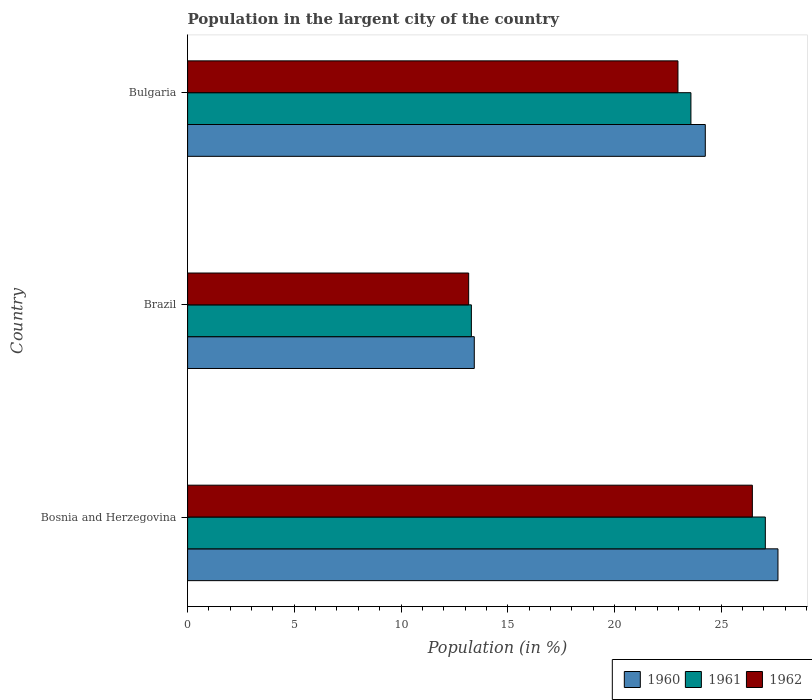How many different coloured bars are there?
Ensure brevity in your answer.  3. Are the number of bars per tick equal to the number of legend labels?
Provide a short and direct response. Yes. Are the number of bars on each tick of the Y-axis equal?
Ensure brevity in your answer.  Yes. How many bars are there on the 2nd tick from the bottom?
Your response must be concise. 3. In how many cases, is the number of bars for a given country not equal to the number of legend labels?
Your answer should be very brief. 0. What is the percentage of population in the largent city in 1961 in Brazil?
Offer a very short reply. 13.3. Across all countries, what is the maximum percentage of population in the largent city in 1961?
Ensure brevity in your answer.  27.07. Across all countries, what is the minimum percentage of population in the largent city in 1960?
Provide a succinct answer. 13.43. In which country was the percentage of population in the largent city in 1962 maximum?
Provide a succinct answer. Bosnia and Herzegovina. In which country was the percentage of population in the largent city in 1961 minimum?
Your answer should be compact. Brazil. What is the total percentage of population in the largent city in 1962 in the graph?
Give a very brief answer. 62.61. What is the difference between the percentage of population in the largent city in 1962 in Brazil and that in Bulgaria?
Give a very brief answer. -9.81. What is the difference between the percentage of population in the largent city in 1962 in Bosnia and Herzegovina and the percentage of population in the largent city in 1960 in Brazil?
Keep it short and to the point. 13.03. What is the average percentage of population in the largent city in 1962 per country?
Offer a very short reply. 20.87. What is the difference between the percentage of population in the largent city in 1960 and percentage of population in the largent city in 1962 in Brazil?
Your answer should be very brief. 0.26. What is the ratio of the percentage of population in the largent city in 1961 in Bosnia and Herzegovina to that in Bulgaria?
Keep it short and to the point. 1.15. Is the difference between the percentage of population in the largent city in 1960 in Bosnia and Herzegovina and Brazil greater than the difference between the percentage of population in the largent city in 1962 in Bosnia and Herzegovina and Brazil?
Make the answer very short. Yes. What is the difference between the highest and the second highest percentage of population in the largent city in 1960?
Your response must be concise. 3.41. What is the difference between the highest and the lowest percentage of population in the largent city in 1961?
Provide a succinct answer. 13.77. Is the sum of the percentage of population in the largent city in 1961 in Bosnia and Herzegovina and Bulgaria greater than the maximum percentage of population in the largent city in 1960 across all countries?
Your response must be concise. Yes. What does the 3rd bar from the bottom in Bosnia and Herzegovina represents?
Your answer should be compact. 1962. How many bars are there?
Your answer should be compact. 9. How many countries are there in the graph?
Give a very brief answer. 3. Are the values on the major ticks of X-axis written in scientific E-notation?
Give a very brief answer. No. Does the graph contain grids?
Ensure brevity in your answer.  No. Where does the legend appear in the graph?
Provide a succinct answer. Bottom right. How many legend labels are there?
Provide a short and direct response. 3. How are the legend labels stacked?
Your answer should be compact. Horizontal. What is the title of the graph?
Your answer should be compact. Population in the largent city of the country. What is the label or title of the X-axis?
Make the answer very short. Population (in %). What is the Population (in %) in 1960 in Bosnia and Herzegovina?
Your response must be concise. 27.66. What is the Population (in %) in 1961 in Bosnia and Herzegovina?
Offer a terse response. 27.07. What is the Population (in %) of 1962 in Bosnia and Herzegovina?
Provide a succinct answer. 26.46. What is the Population (in %) of 1960 in Brazil?
Provide a short and direct response. 13.43. What is the Population (in %) in 1961 in Brazil?
Provide a succinct answer. 13.3. What is the Population (in %) of 1962 in Brazil?
Your answer should be very brief. 13.17. What is the Population (in %) of 1960 in Bulgaria?
Your answer should be very brief. 24.26. What is the Population (in %) in 1961 in Bulgaria?
Keep it short and to the point. 23.59. What is the Population (in %) of 1962 in Bulgaria?
Provide a succinct answer. 22.98. Across all countries, what is the maximum Population (in %) in 1960?
Ensure brevity in your answer.  27.66. Across all countries, what is the maximum Population (in %) in 1961?
Provide a short and direct response. 27.07. Across all countries, what is the maximum Population (in %) in 1962?
Your response must be concise. 26.46. Across all countries, what is the minimum Population (in %) of 1960?
Your answer should be very brief. 13.43. Across all countries, what is the minimum Population (in %) of 1961?
Make the answer very short. 13.3. Across all countries, what is the minimum Population (in %) in 1962?
Offer a very short reply. 13.17. What is the total Population (in %) of 1960 in the graph?
Ensure brevity in your answer.  65.36. What is the total Population (in %) in 1961 in the graph?
Provide a short and direct response. 63.95. What is the total Population (in %) in 1962 in the graph?
Your answer should be compact. 62.61. What is the difference between the Population (in %) of 1960 in Bosnia and Herzegovina and that in Brazil?
Your response must be concise. 14.23. What is the difference between the Population (in %) of 1961 in Bosnia and Herzegovina and that in Brazil?
Keep it short and to the point. 13.77. What is the difference between the Population (in %) in 1962 in Bosnia and Herzegovina and that in Brazil?
Provide a succinct answer. 13.29. What is the difference between the Population (in %) in 1960 in Bosnia and Herzegovina and that in Bulgaria?
Provide a succinct answer. 3.41. What is the difference between the Population (in %) of 1961 in Bosnia and Herzegovina and that in Bulgaria?
Your answer should be compact. 3.49. What is the difference between the Population (in %) of 1962 in Bosnia and Herzegovina and that in Bulgaria?
Your response must be concise. 3.49. What is the difference between the Population (in %) in 1960 in Brazil and that in Bulgaria?
Offer a very short reply. -10.83. What is the difference between the Population (in %) in 1961 in Brazil and that in Bulgaria?
Your response must be concise. -10.29. What is the difference between the Population (in %) of 1962 in Brazil and that in Bulgaria?
Ensure brevity in your answer.  -9.81. What is the difference between the Population (in %) in 1960 in Bosnia and Herzegovina and the Population (in %) in 1961 in Brazil?
Your response must be concise. 14.37. What is the difference between the Population (in %) in 1960 in Bosnia and Herzegovina and the Population (in %) in 1962 in Brazil?
Ensure brevity in your answer.  14.49. What is the difference between the Population (in %) of 1961 in Bosnia and Herzegovina and the Population (in %) of 1962 in Brazil?
Provide a succinct answer. 13.9. What is the difference between the Population (in %) in 1960 in Bosnia and Herzegovina and the Population (in %) in 1961 in Bulgaria?
Offer a very short reply. 4.08. What is the difference between the Population (in %) in 1960 in Bosnia and Herzegovina and the Population (in %) in 1962 in Bulgaria?
Provide a succinct answer. 4.69. What is the difference between the Population (in %) of 1961 in Bosnia and Herzegovina and the Population (in %) of 1962 in Bulgaria?
Keep it short and to the point. 4.09. What is the difference between the Population (in %) in 1960 in Brazil and the Population (in %) in 1961 in Bulgaria?
Ensure brevity in your answer.  -10.15. What is the difference between the Population (in %) in 1960 in Brazil and the Population (in %) in 1962 in Bulgaria?
Give a very brief answer. -9.54. What is the difference between the Population (in %) in 1961 in Brazil and the Population (in %) in 1962 in Bulgaria?
Provide a succinct answer. -9.68. What is the average Population (in %) of 1960 per country?
Your answer should be compact. 21.79. What is the average Population (in %) of 1961 per country?
Your answer should be very brief. 21.32. What is the average Population (in %) in 1962 per country?
Your answer should be compact. 20.87. What is the difference between the Population (in %) in 1960 and Population (in %) in 1961 in Bosnia and Herzegovina?
Keep it short and to the point. 0.59. What is the difference between the Population (in %) in 1960 and Population (in %) in 1962 in Bosnia and Herzegovina?
Keep it short and to the point. 1.2. What is the difference between the Population (in %) of 1961 and Population (in %) of 1962 in Bosnia and Herzegovina?
Provide a succinct answer. 0.61. What is the difference between the Population (in %) of 1960 and Population (in %) of 1961 in Brazil?
Your answer should be very brief. 0.14. What is the difference between the Population (in %) in 1960 and Population (in %) in 1962 in Brazil?
Ensure brevity in your answer.  0.26. What is the difference between the Population (in %) in 1961 and Population (in %) in 1962 in Brazil?
Provide a succinct answer. 0.13. What is the difference between the Population (in %) in 1960 and Population (in %) in 1961 in Bulgaria?
Ensure brevity in your answer.  0.67. What is the difference between the Population (in %) in 1960 and Population (in %) in 1962 in Bulgaria?
Your response must be concise. 1.28. What is the difference between the Population (in %) of 1961 and Population (in %) of 1962 in Bulgaria?
Provide a succinct answer. 0.61. What is the ratio of the Population (in %) of 1960 in Bosnia and Herzegovina to that in Brazil?
Provide a succinct answer. 2.06. What is the ratio of the Population (in %) of 1961 in Bosnia and Herzegovina to that in Brazil?
Give a very brief answer. 2.04. What is the ratio of the Population (in %) in 1962 in Bosnia and Herzegovina to that in Brazil?
Your response must be concise. 2.01. What is the ratio of the Population (in %) in 1960 in Bosnia and Herzegovina to that in Bulgaria?
Your response must be concise. 1.14. What is the ratio of the Population (in %) in 1961 in Bosnia and Herzegovina to that in Bulgaria?
Offer a very short reply. 1.15. What is the ratio of the Population (in %) of 1962 in Bosnia and Herzegovina to that in Bulgaria?
Offer a very short reply. 1.15. What is the ratio of the Population (in %) of 1960 in Brazil to that in Bulgaria?
Offer a terse response. 0.55. What is the ratio of the Population (in %) in 1961 in Brazil to that in Bulgaria?
Provide a short and direct response. 0.56. What is the ratio of the Population (in %) in 1962 in Brazil to that in Bulgaria?
Provide a short and direct response. 0.57. What is the difference between the highest and the second highest Population (in %) in 1960?
Keep it short and to the point. 3.41. What is the difference between the highest and the second highest Population (in %) of 1961?
Provide a succinct answer. 3.49. What is the difference between the highest and the second highest Population (in %) in 1962?
Your answer should be compact. 3.49. What is the difference between the highest and the lowest Population (in %) in 1960?
Ensure brevity in your answer.  14.23. What is the difference between the highest and the lowest Population (in %) of 1961?
Your response must be concise. 13.77. What is the difference between the highest and the lowest Population (in %) in 1962?
Provide a short and direct response. 13.29. 